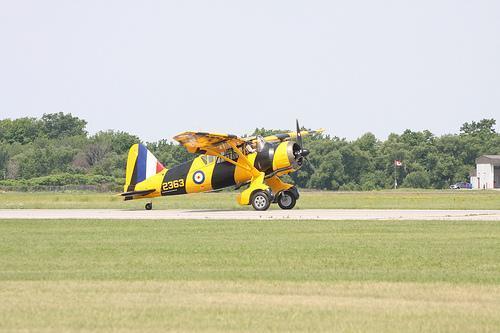How many airplanes are there?
Give a very brief answer. 1. How many dinosaurs are in the picture?
Give a very brief answer. 0. How many people are riding on elephants?
Give a very brief answer. 0. How many elephants are pictured?
Give a very brief answer. 0. 